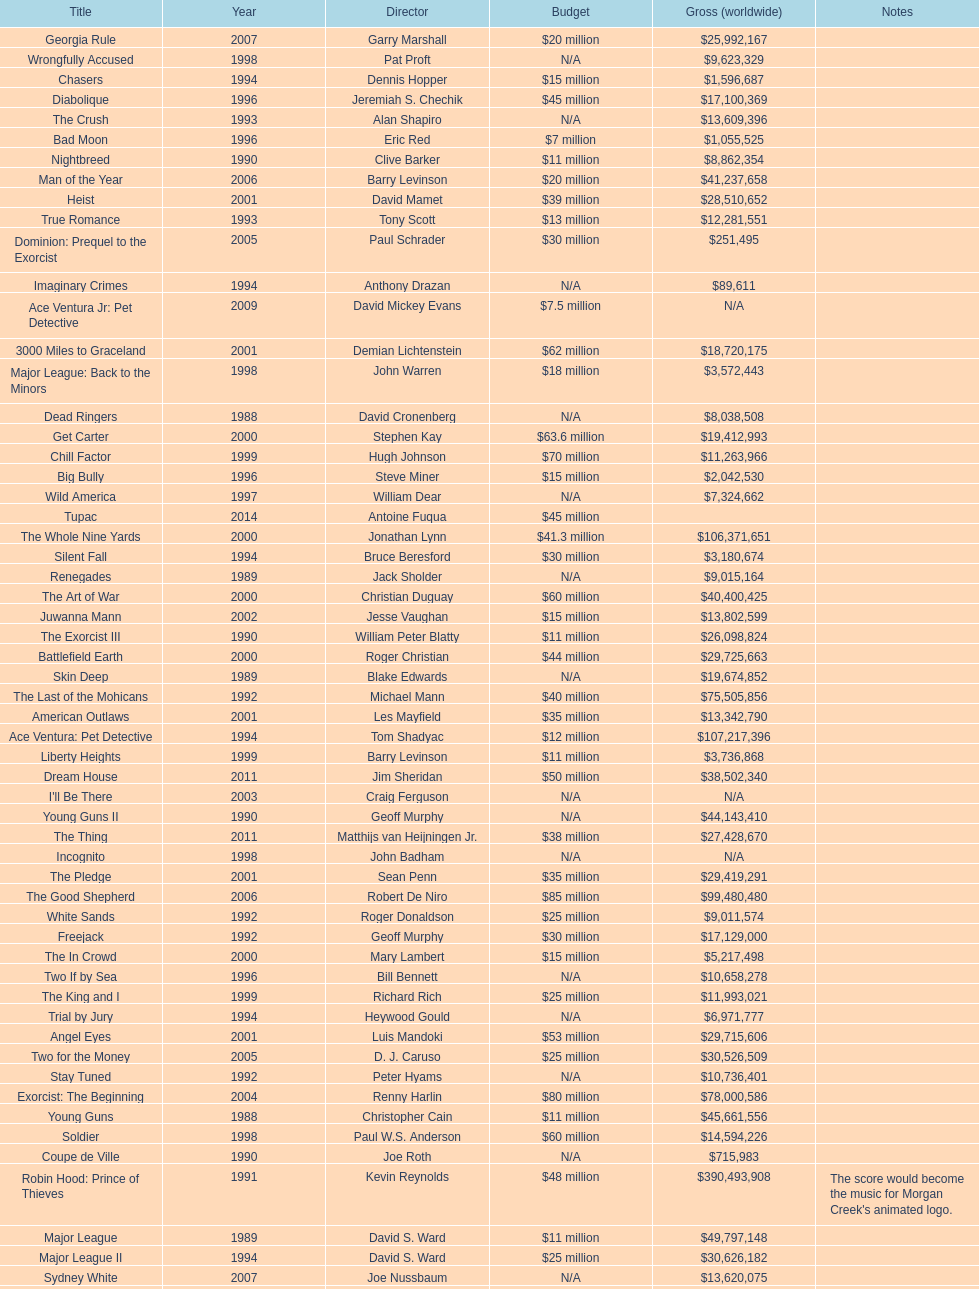How many films did morgan creek make in 2006? 2. 